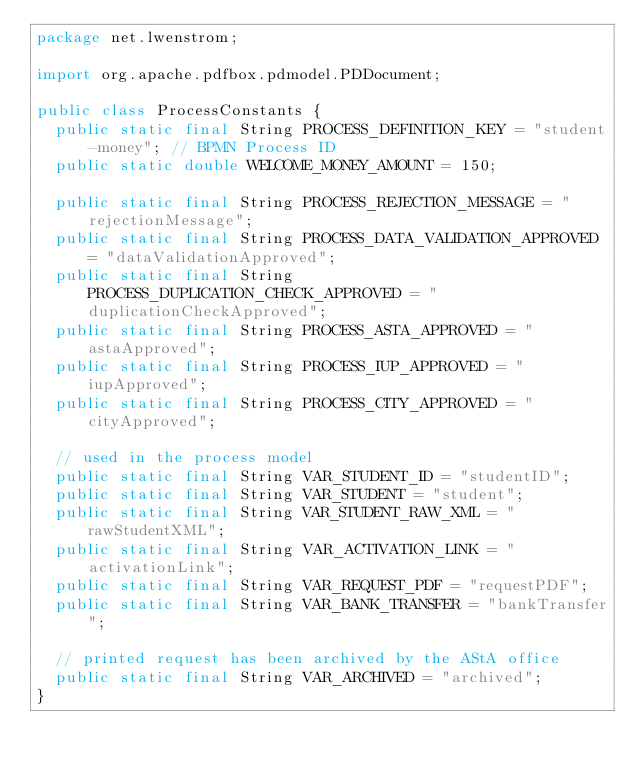Convert code to text. <code><loc_0><loc_0><loc_500><loc_500><_Java_>package net.lwenstrom;

import org.apache.pdfbox.pdmodel.PDDocument;

public class ProcessConstants {
  public static final String PROCESS_DEFINITION_KEY = "student-money"; // BPMN Process ID
  public static double WELCOME_MONEY_AMOUNT = 150;

  public static final String PROCESS_REJECTION_MESSAGE = "rejectionMessage";
  public static final String PROCESS_DATA_VALIDATION_APPROVED = "dataValidationApproved";
  public static final String PROCESS_DUPLICATION_CHECK_APPROVED = "duplicationCheckApproved";
  public static final String PROCESS_ASTA_APPROVED = "astaApproved";
  public static final String PROCESS_IUP_APPROVED = "iupApproved";
  public static final String PROCESS_CITY_APPROVED = "cityApproved";

  // used in the process model
  public static final String VAR_STUDENT_ID = "studentID";
  public static final String VAR_STUDENT = "student";
  public static final String VAR_STUDENT_RAW_XML = "rawStudentXML";
  public static final String VAR_ACTIVATION_LINK = "activationLink";
  public static final String VAR_REQUEST_PDF = "requestPDF";
  public static final String VAR_BANK_TRANSFER = "bankTransfer";

  // printed request has been archived by the AStA office
  public static final String VAR_ARCHIVED = "archived";
}
</code> 